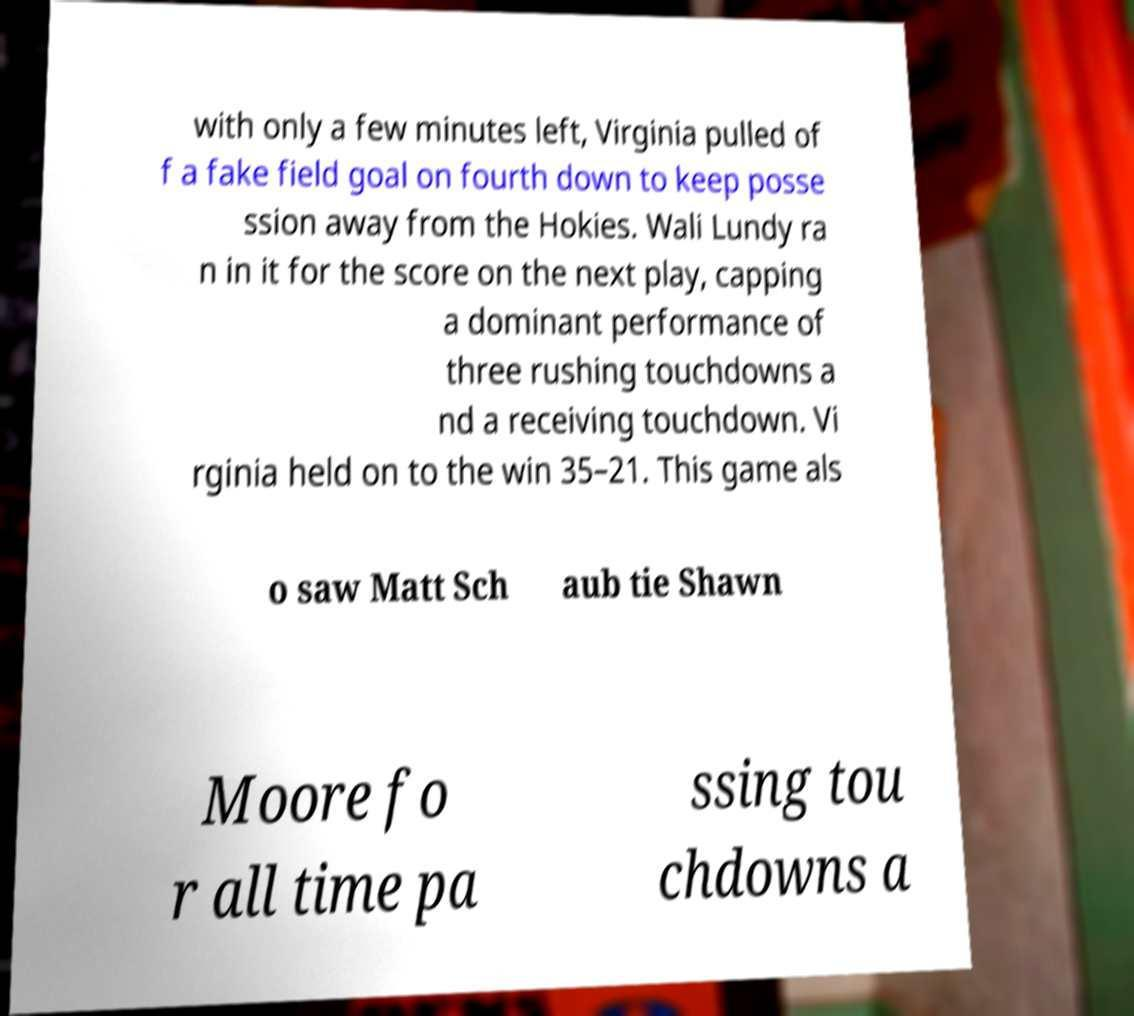For documentation purposes, I need the text within this image transcribed. Could you provide that? with only a few minutes left, Virginia pulled of f a fake field goal on fourth down to keep posse ssion away from the Hokies. Wali Lundy ra n in it for the score on the next play, capping a dominant performance of three rushing touchdowns a nd a receiving touchdown. Vi rginia held on to the win 35–21. This game als o saw Matt Sch aub tie Shawn Moore fo r all time pa ssing tou chdowns a 